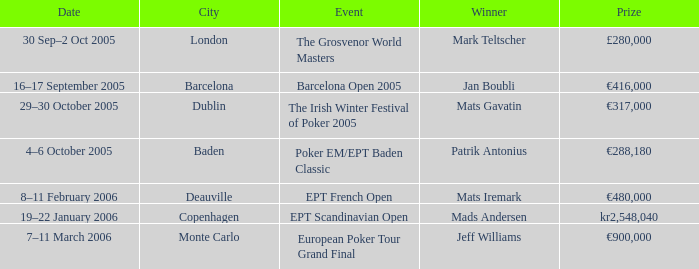When was the event in the City of Baden? 4–6 October 2005. 